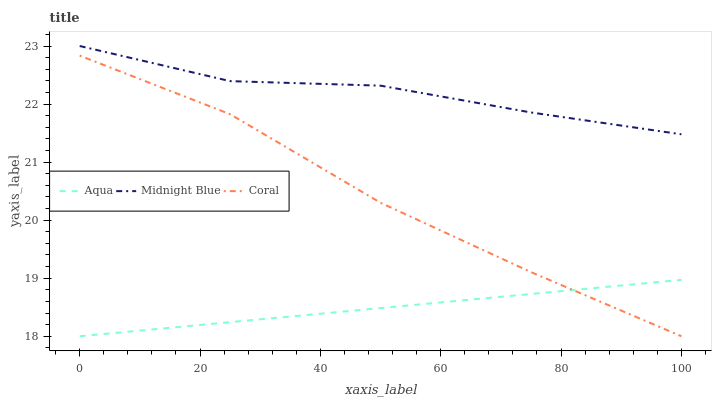Does Midnight Blue have the minimum area under the curve?
Answer yes or no. No. Does Aqua have the maximum area under the curve?
Answer yes or no. No. Is Midnight Blue the smoothest?
Answer yes or no. No. Is Aqua the roughest?
Answer yes or no. No. Does Midnight Blue have the lowest value?
Answer yes or no. No. Does Aqua have the highest value?
Answer yes or no. No. Is Coral less than Midnight Blue?
Answer yes or no. Yes. Is Midnight Blue greater than Coral?
Answer yes or no. Yes. Does Coral intersect Midnight Blue?
Answer yes or no. No. 